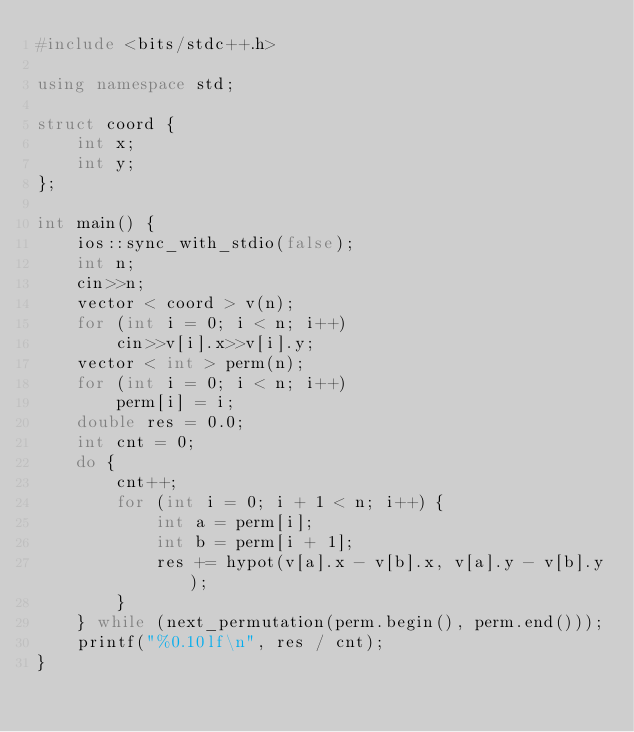<code> <loc_0><loc_0><loc_500><loc_500><_C++_>#include <bits/stdc++.h>

using namespace std;

struct coord {
	int x;
	int y;
};

int main() {
	ios::sync_with_stdio(false);
	int n;
	cin>>n;
	vector < coord > v(n);
	for (int i = 0; i < n; i++)
		cin>>v[i].x>>v[i].y;
	vector < int > perm(n);
	for (int i = 0; i < n; i++)
		perm[i] = i;
	double res = 0.0;
	int cnt = 0;
	do {
		cnt++;
		for (int i = 0; i + 1 < n; i++) {
			int a = perm[i];
			int b = perm[i + 1];
			res += hypot(v[a].x - v[b].x, v[a].y - v[b].y);
		}
	} while (next_permutation(perm.begin(), perm.end()));
	printf("%0.10lf\n", res / cnt);
}
</code> 